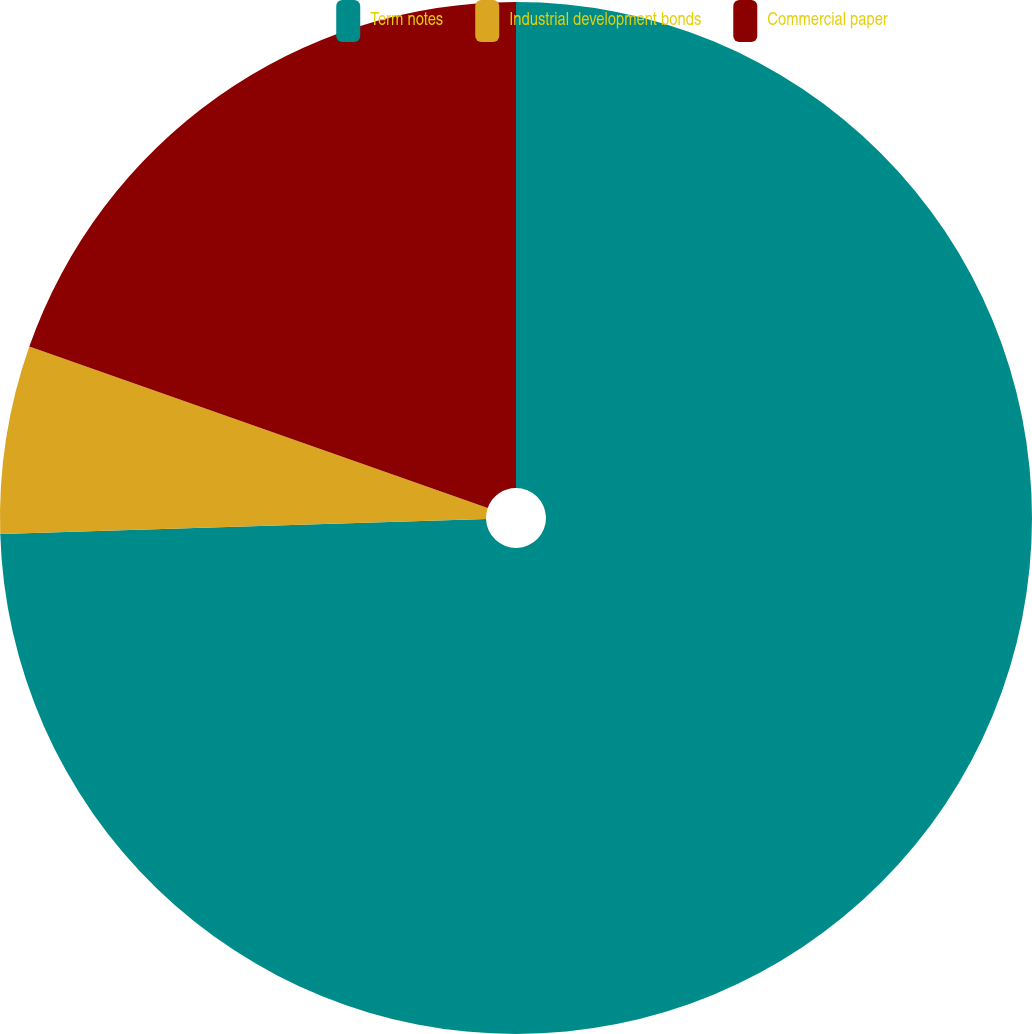Convert chart. <chart><loc_0><loc_0><loc_500><loc_500><pie_chart><fcel>Term notes<fcel>Industrial development bonds<fcel>Commercial paper<nl><fcel>74.51%<fcel>5.88%<fcel>19.61%<nl></chart> 